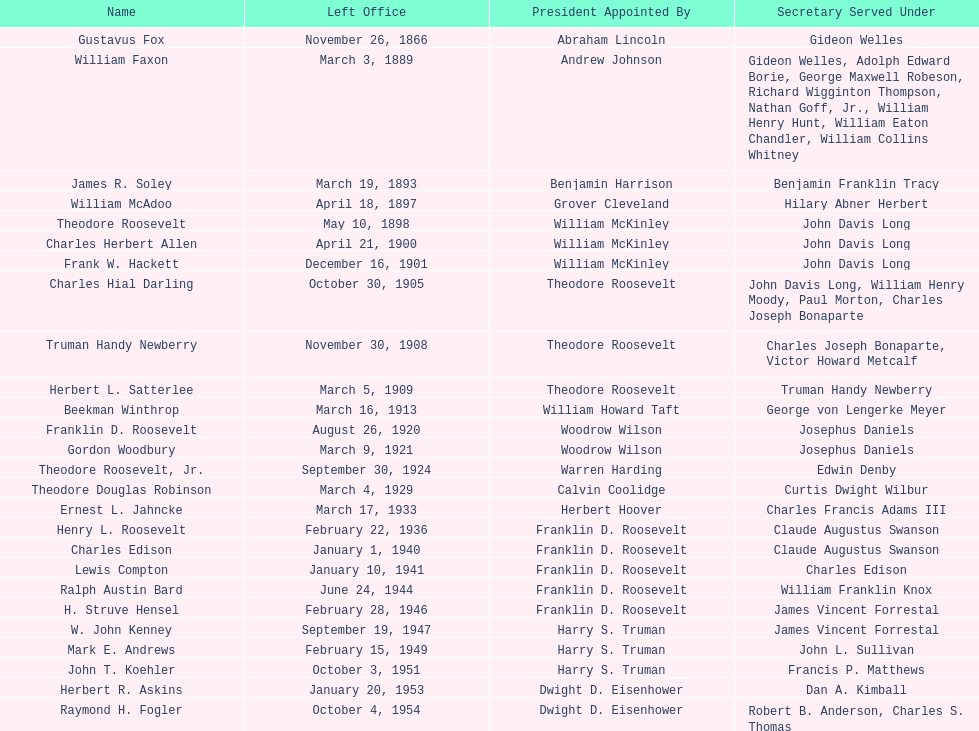Who held the position of first assistant secretary of the navy? Gustavus Fox. 